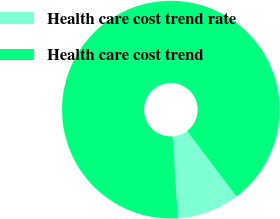Convert chart. <chart><loc_0><loc_0><loc_500><loc_500><pie_chart><fcel>Health care cost trend rate<fcel>Health care cost trend<nl><fcel>9.27%<fcel>90.73%<nl></chart> 